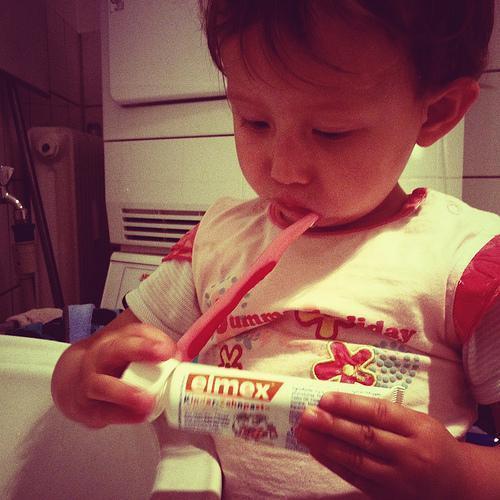How many vents in the dryer?
Give a very brief answer. 4. How many heaters?
Give a very brief answer. 1. 